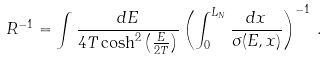<formula> <loc_0><loc_0><loc_500><loc_500>R ^ { - 1 } = \int \frac { d E } { 4 T \cosh ^ { 2 } \left ( \frac { E } { 2 T } \right ) } \left ( \int _ { 0 } ^ { L _ { N } } \frac { d x } { \sigma ( E , x ) } \right ) ^ { - 1 } \, .</formula> 